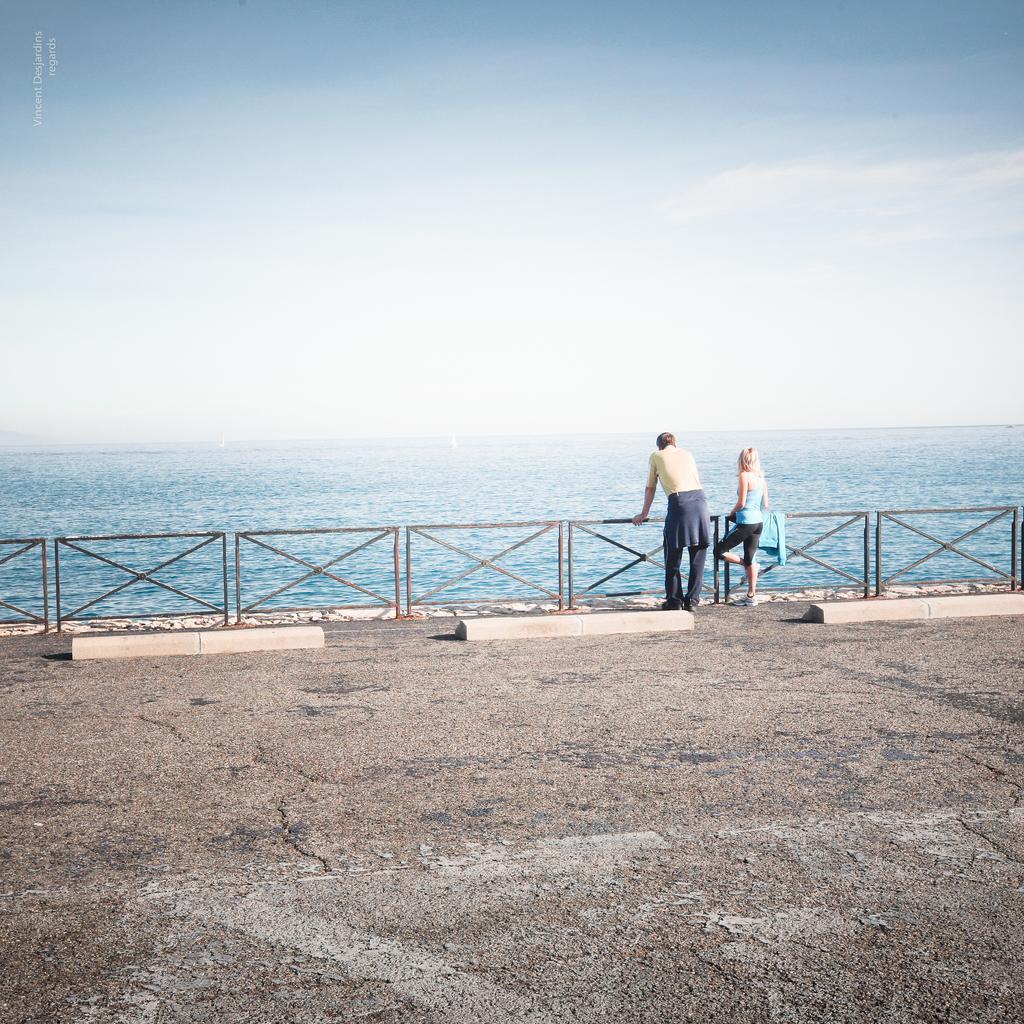Describe this image in one or two sentences. In this image we can see two persons standing near to the railing. In the background there is water and sky. 